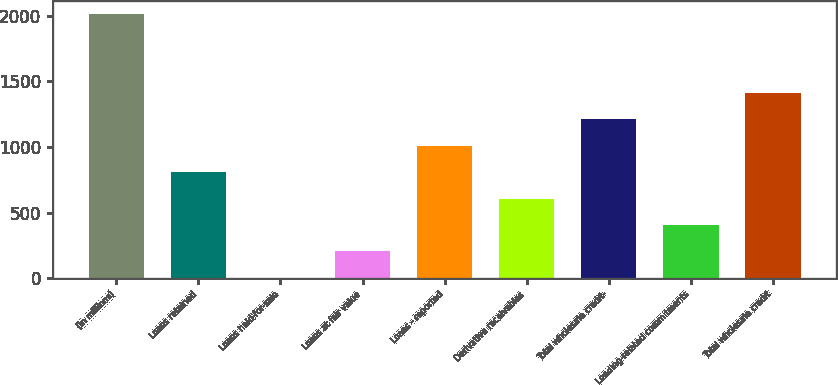Convert chart. <chart><loc_0><loc_0><loc_500><loc_500><bar_chart><fcel>(in millions)<fcel>Loans retained<fcel>Loans held-for-sale<fcel>Loans at fair value<fcel>Loans - reported<fcel>Derivative receivables<fcel>Total wholesale credit-<fcel>Lending-related commitments<fcel>Total wholesale credit<nl><fcel>2014<fcel>808<fcel>4<fcel>205<fcel>1009<fcel>607<fcel>1210<fcel>406<fcel>1411<nl></chart> 